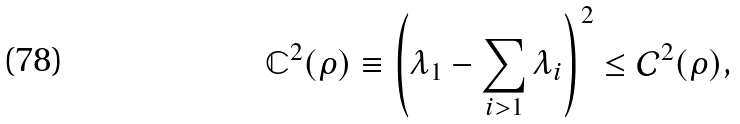Convert formula to latex. <formula><loc_0><loc_0><loc_500><loc_500>\mathbb { C } ^ { 2 } ( \rho ) \equiv \left ( \lambda _ { 1 } - \sum _ { i > 1 } \lambda _ { i } \right ) ^ { 2 } \leq \mathcal { C } ^ { 2 } ( \rho ) ,</formula> 